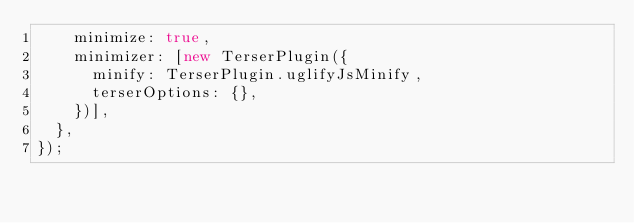<code> <loc_0><loc_0><loc_500><loc_500><_JavaScript_>    minimize: true,
    minimizer: [new TerserPlugin({
      minify: TerserPlugin.uglifyJsMinify,
      terserOptions: {},
    })],
  },
});
</code> 